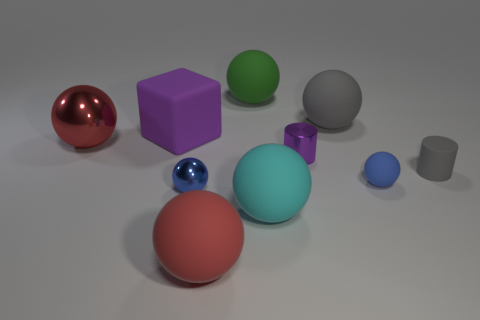Subtract all green balls. How many balls are left? 6 Subtract all cyan spheres. How many spheres are left? 6 Subtract 2 balls. How many balls are left? 5 Subtract all yellow spheres. Subtract all purple blocks. How many spheres are left? 7 Subtract all cubes. How many objects are left? 9 Add 2 rubber things. How many rubber things are left? 9 Add 4 large yellow rubber objects. How many large yellow rubber objects exist? 4 Subtract 0 brown spheres. How many objects are left? 10 Subtract all tiny metal cylinders. Subtract all cyan balls. How many objects are left? 8 